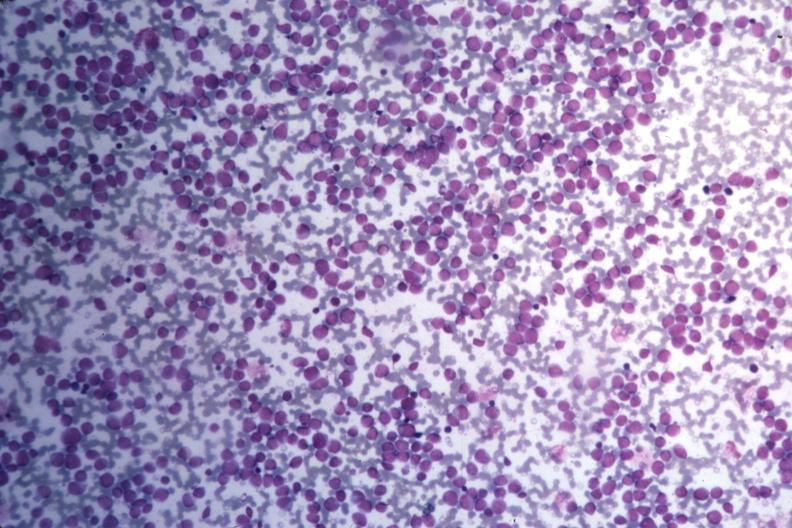do med wrights stain many pleomorphic blast cells readily seen?
Answer the question using a single word or phrase. Yes 